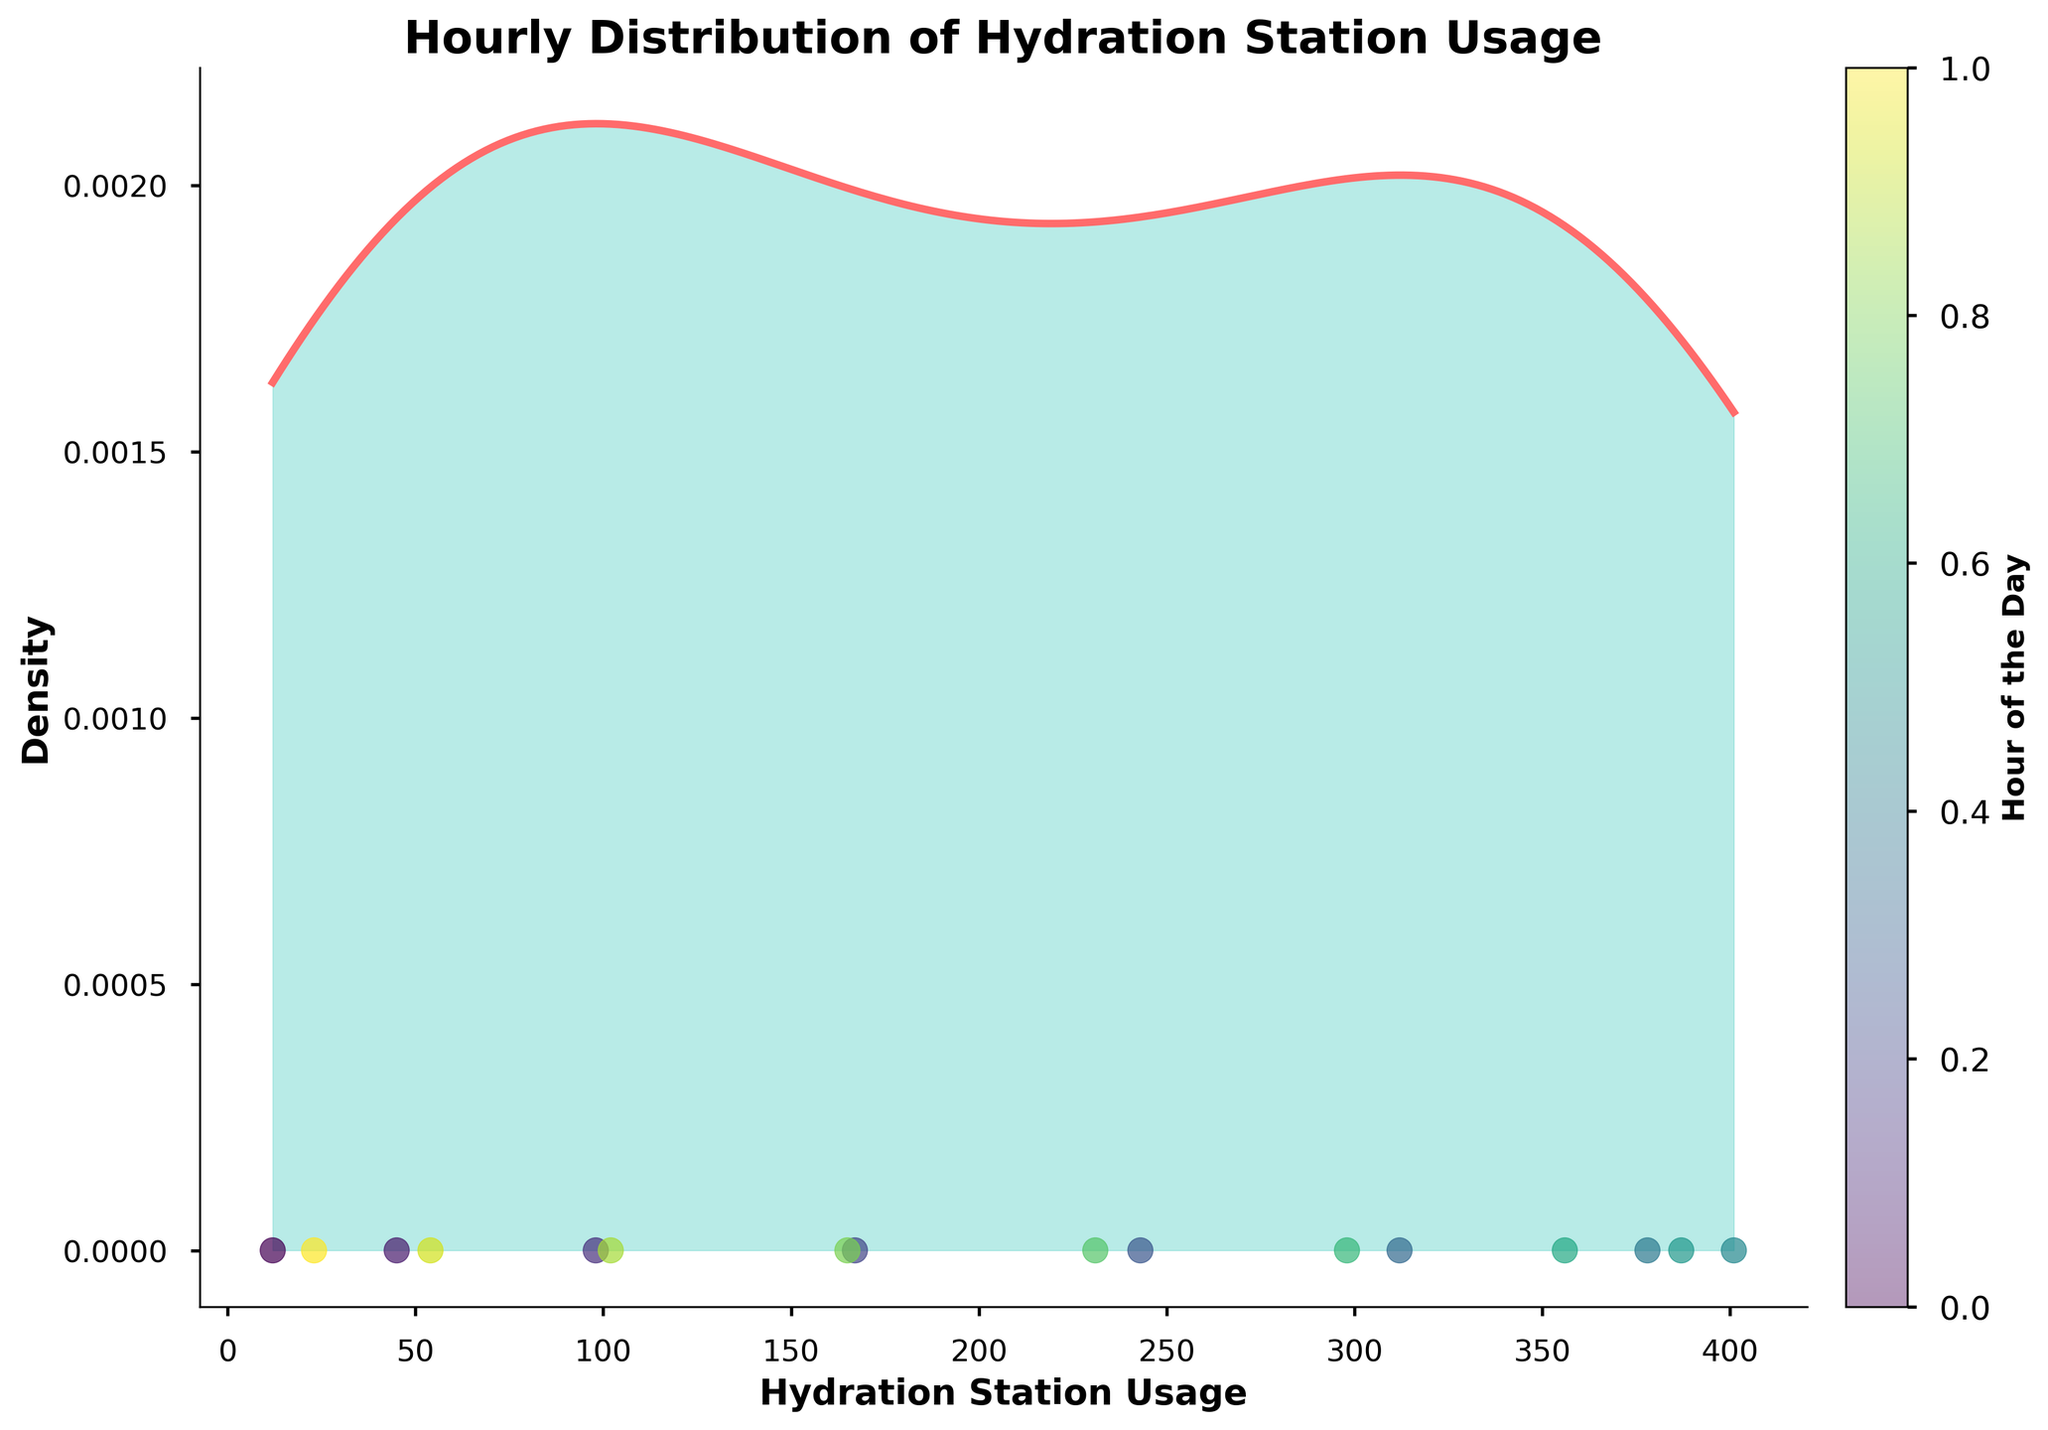what is the title of the graph? The title of the graph is displayed at the top, indicating the main subject of the figure. The title says, "Hourly Distribution of Hydration Station Usage".
Answer: Hourly Distribution of Hydration Station Usage what is the value of the x-axis closest to the highest point in density? The x-axis represents the "Hydration Station Usage", and the highest point in density will be at the peak of the density curve. To find the x-axis value corresponding to this peak, one can visually locate it.
Answer: Approximately 350 around which hour(s) does the hydration station usage start to decrease after a peak? By examining the figure, we can look for the hours whose points on the density plot correspond to the decline in the density curve after the peak. The usage decreases notably after hour 12.
Answer: Around 12 PM how does the density distribution change before and after 12 PM? To compare the density distribution before and after 12 PM, notice that the density curve increases up to 12 PM and then it decreases afterward. This shows that the usage density is high before 12 PM and drops after.
Answer: It increases before and decreases after which hours have the least hydration station usage? To determine the hours with the least usage, look at the scatter plot at the bottom and identify the points farthest left, representing the lowest use. These are around early morning and late evening hours.
Answer: 5 AM and 8 PM what is the relationship between hourly distribution and density? The figure shows that as the hourly distribution of hydration station usage changes, the density of that usage also changes, peaking when the most users are present and falling when fewer users are around.
Answer: Density increases when hourly usage increases and vice versa 